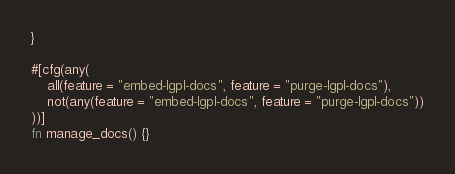Convert code to text. <code><loc_0><loc_0><loc_500><loc_500><_Rust_>}

#[cfg(any(
    all(feature = "embed-lgpl-docs", feature = "purge-lgpl-docs"),
    not(any(feature = "embed-lgpl-docs", feature = "purge-lgpl-docs"))
))]
fn manage_docs() {}
</code> 